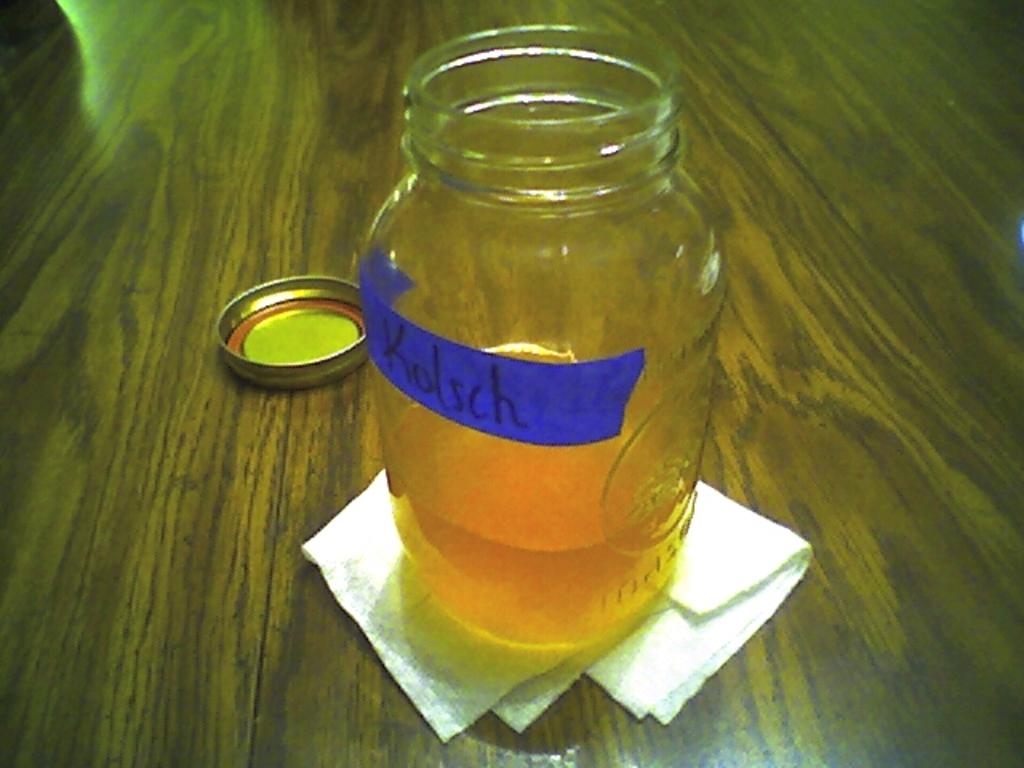<image>
Provide a brief description of the given image. open glass mason jar with blue piece of tape that says kolsch 